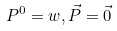Convert formula to latex. <formula><loc_0><loc_0><loc_500><loc_500>P ^ { 0 } = w , \vec { P } = \vec { 0 }</formula> 